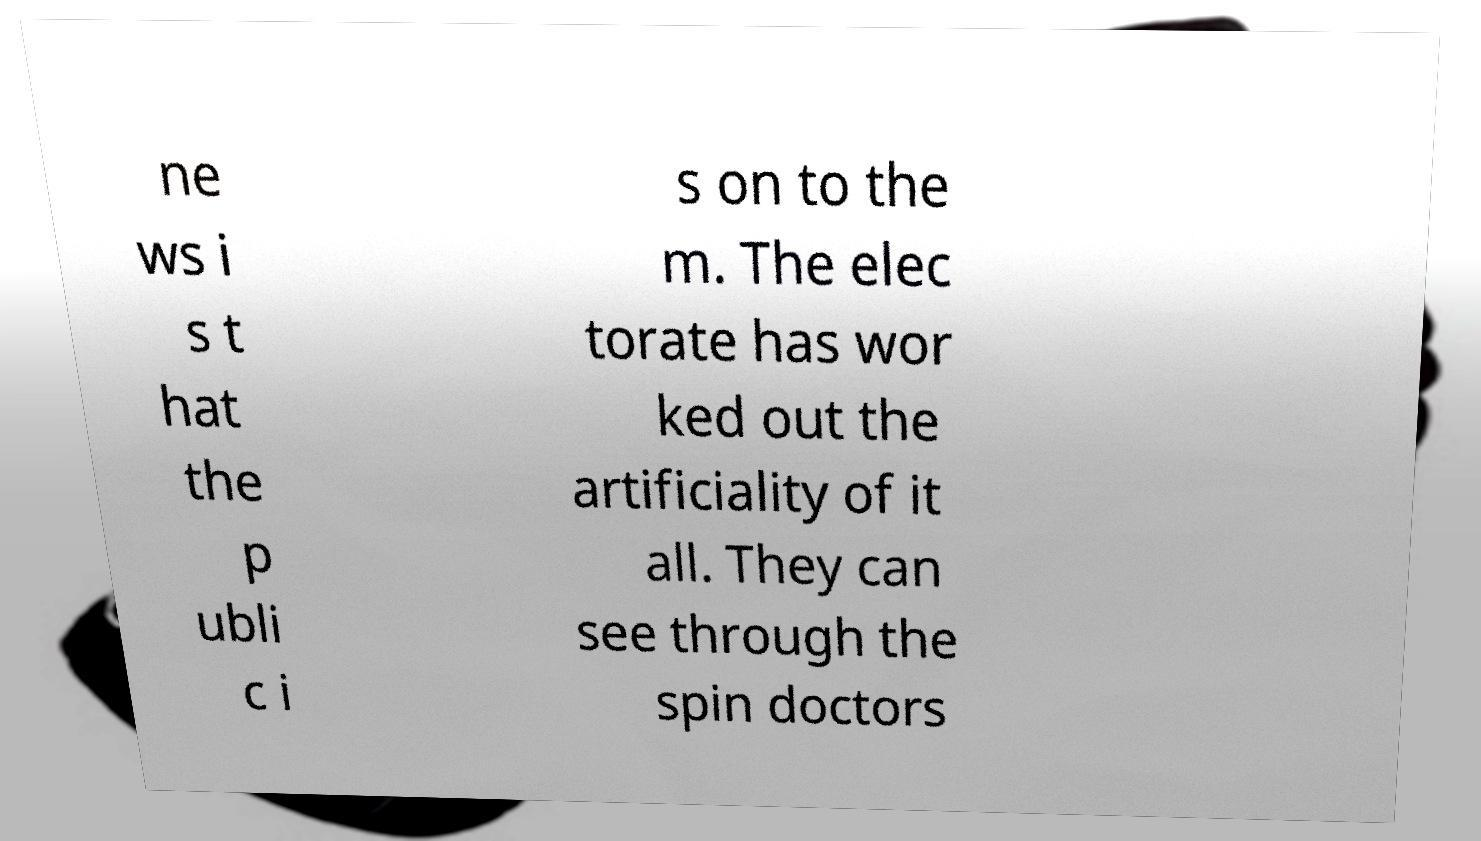What messages or text are displayed in this image? I need them in a readable, typed format. ne ws i s t hat the p ubli c i s on to the m. The elec torate has wor ked out the artificiality of it all. They can see through the spin doctors 